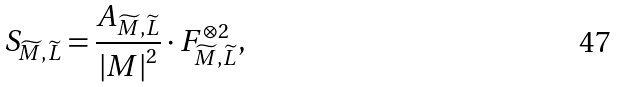<formula> <loc_0><loc_0><loc_500><loc_500>S _ { \widetilde { M } , \widetilde { L } } = \frac { A _ { \widetilde { M } , \widetilde { L } } } { \left | M \right | ^ { 2 } } \cdot F _ { \widetilde { M } , \widetilde { L } } ^ { \otimes 2 } ,</formula> 